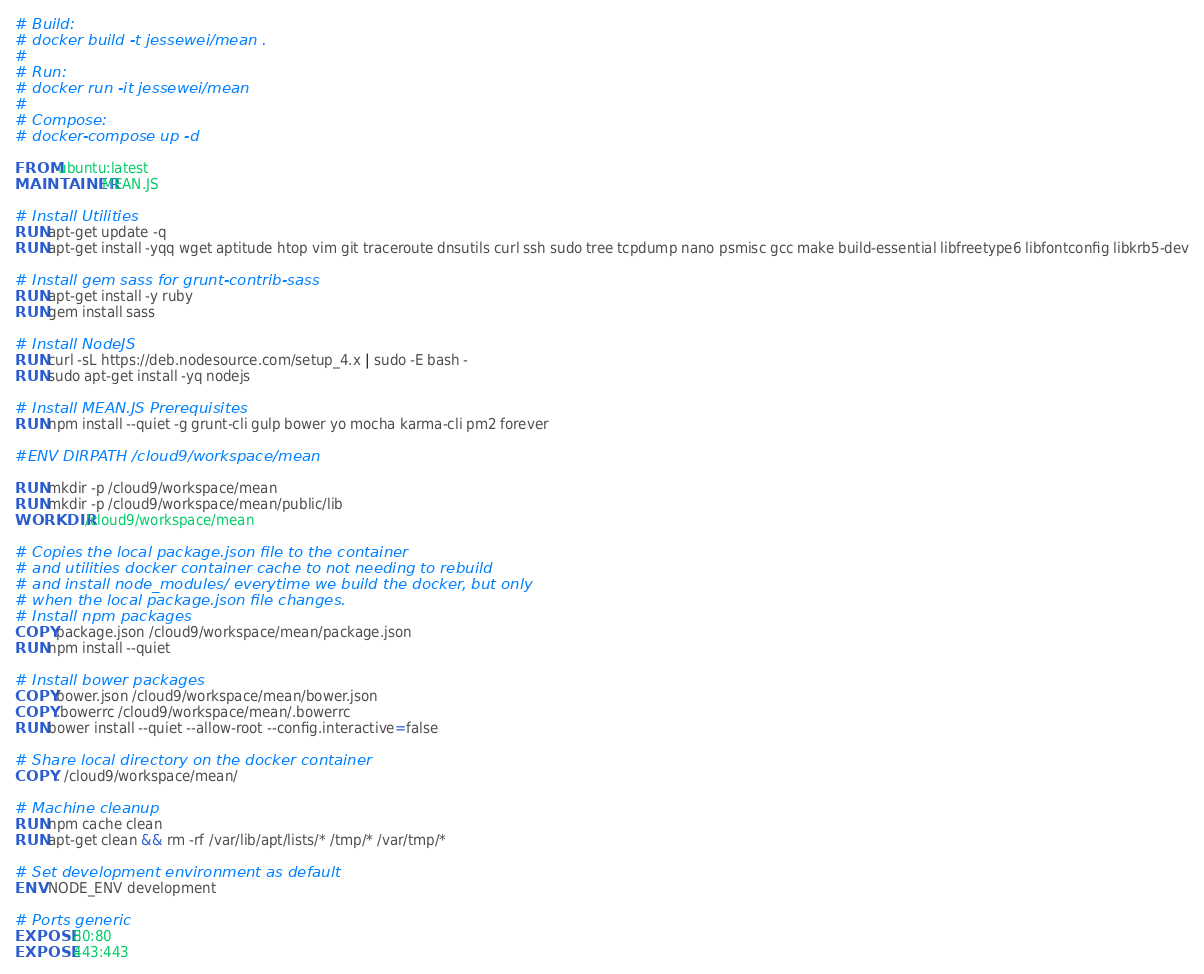<code> <loc_0><loc_0><loc_500><loc_500><_Dockerfile_># Build:
# docker build -t jessewei/mean .
#
# Run:
# docker run -it jessewei/mean
#
# Compose:
# docker-compose up -d

FROM ubuntu:latest
MAINTAINER MEAN.JS

# Install Utilities
RUN apt-get update -q
RUN apt-get install -yqq wget aptitude htop vim git traceroute dnsutils curl ssh sudo tree tcpdump nano psmisc gcc make build-essential libfreetype6 libfontconfig libkrb5-dev

# Install gem sass for grunt-contrib-sass
RUN apt-get install -y ruby
RUN gem install sass

# Install NodeJS
RUN curl -sL https://deb.nodesource.com/setup_4.x | sudo -E bash -
RUN sudo apt-get install -yq nodejs

# Install MEAN.JS Prerequisites
RUN npm install --quiet -g grunt-cli gulp bower yo mocha karma-cli pm2 forever

#ENV DIRPATH /cloud9/workspace/mean

RUN mkdir -p /cloud9/workspace/mean 
RUN mkdir -p /cloud9/workspace/mean/public/lib
WORKDIR /cloud9/workspace/mean

# Copies the local package.json file to the container
# and utilities docker container cache to not needing to rebuild
# and install node_modules/ everytime we build the docker, but only
# when the local package.json file changes.
# Install npm packages
COPY package.json /cloud9/workspace/mean/package.json
RUN npm install --quiet

# Install bower packages
COPY bower.json /cloud9/workspace/mean/bower.json
COPY .bowerrc /cloud9/workspace/mean/.bowerrc
RUN bower install --quiet --allow-root --config.interactive=false

# Share local directory on the docker container
COPY . /cloud9/workspace/mean/

# Machine cleanup
RUN npm cache clean
RUN apt-get clean && rm -rf /var/lib/apt/lists/* /tmp/* /var/tmp/*

# Set development environment as default
ENV NODE_ENV development

# Ports generic
EXPOSE 80:80
EXPOSE 443:443
</code> 